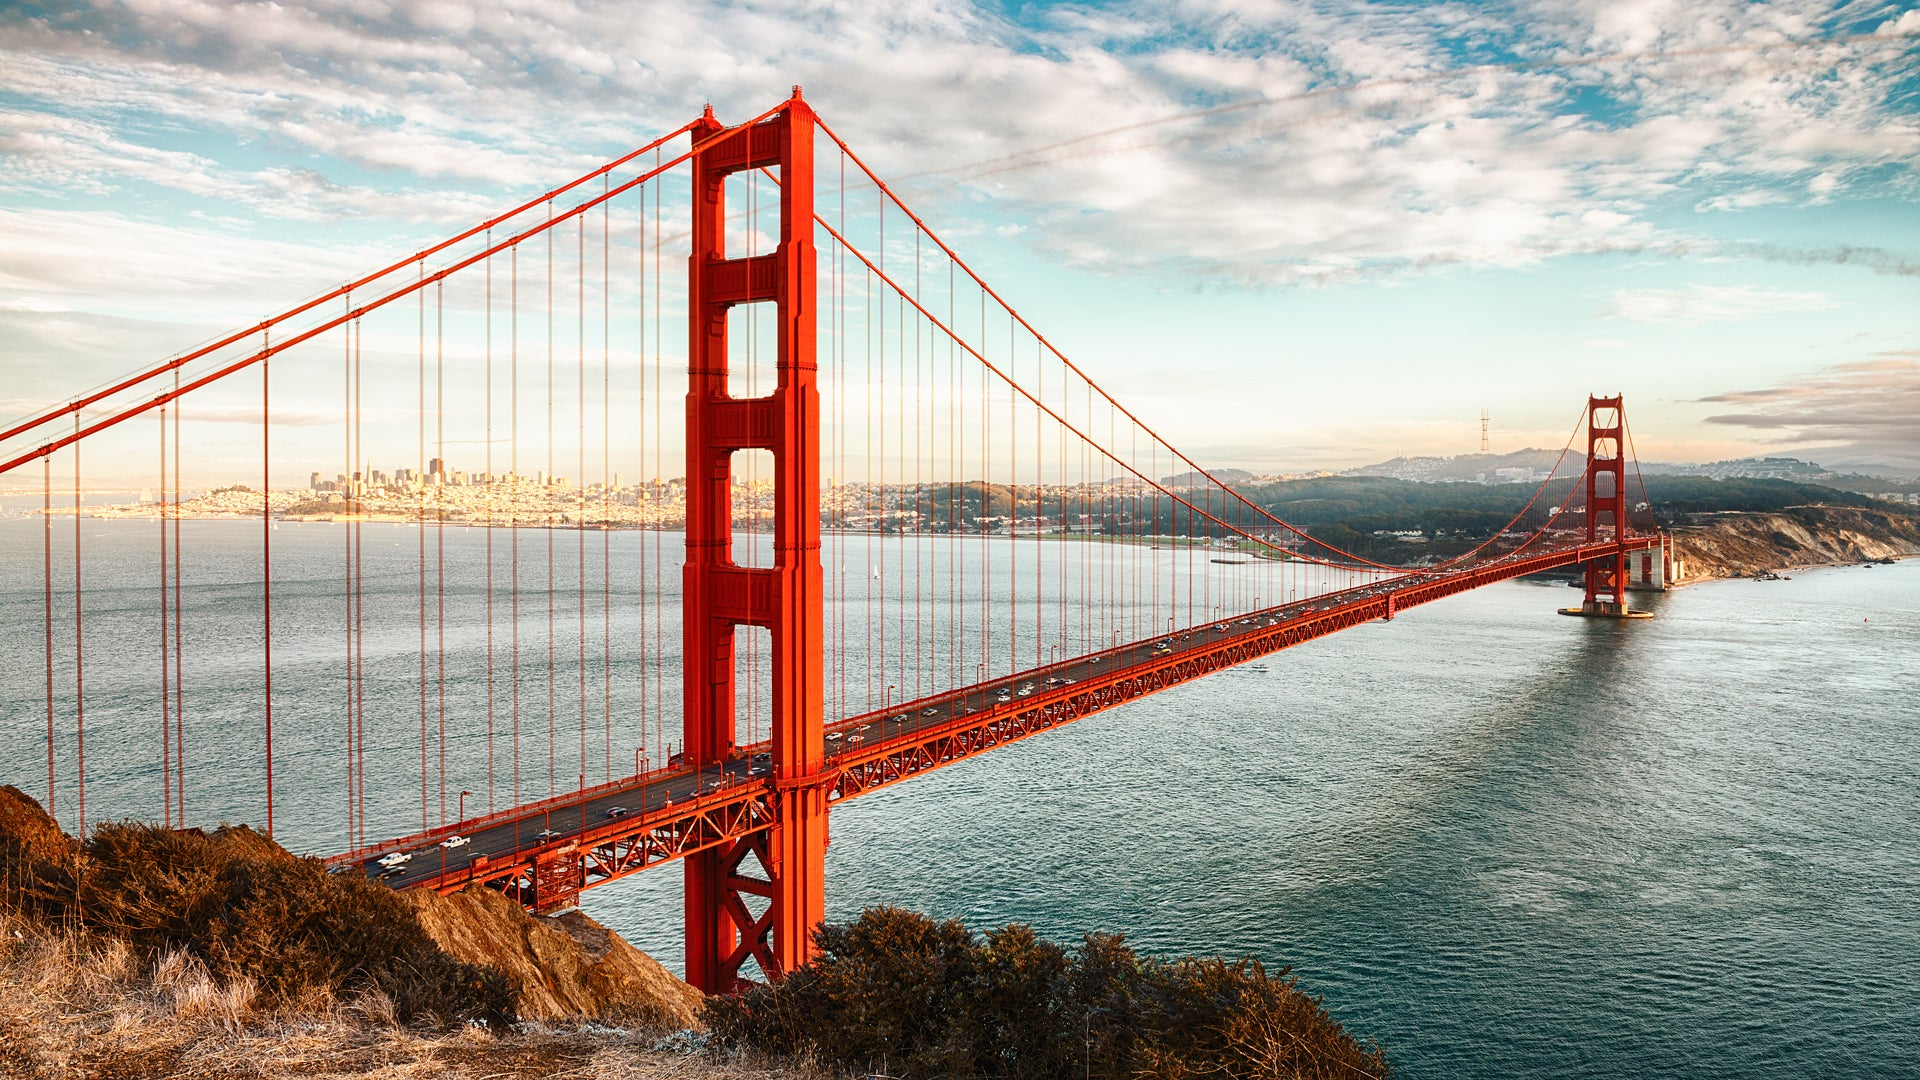Describe a realistic scenario involving people taking photos of the bridge. A group of tourists gathers near the lookout point, their faces brimming with excitement and awe. Cameras and smartphones are raised in unison, capturing the stunning vista of the Golden Gate Bridge. Among them is a professional photographer, carefully adjusting his lens to capture the perfect shot as the sunlight casts a soft glow on the red structure. A couple takes a selfie with the bridge as their backdrop, while a family poses together, ensuring the iconic landmark is prominently featured in every frame. Laughter and chatter fill the air as everyone attempts to preserve the memory of this breathtaking sight. 